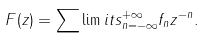Convert formula to latex. <formula><loc_0><loc_0><loc_500><loc_500>F ( z ) = \sum \lim i t s _ { n = - \infty } ^ { + \infty } f _ { n } z ^ { - n } .</formula> 